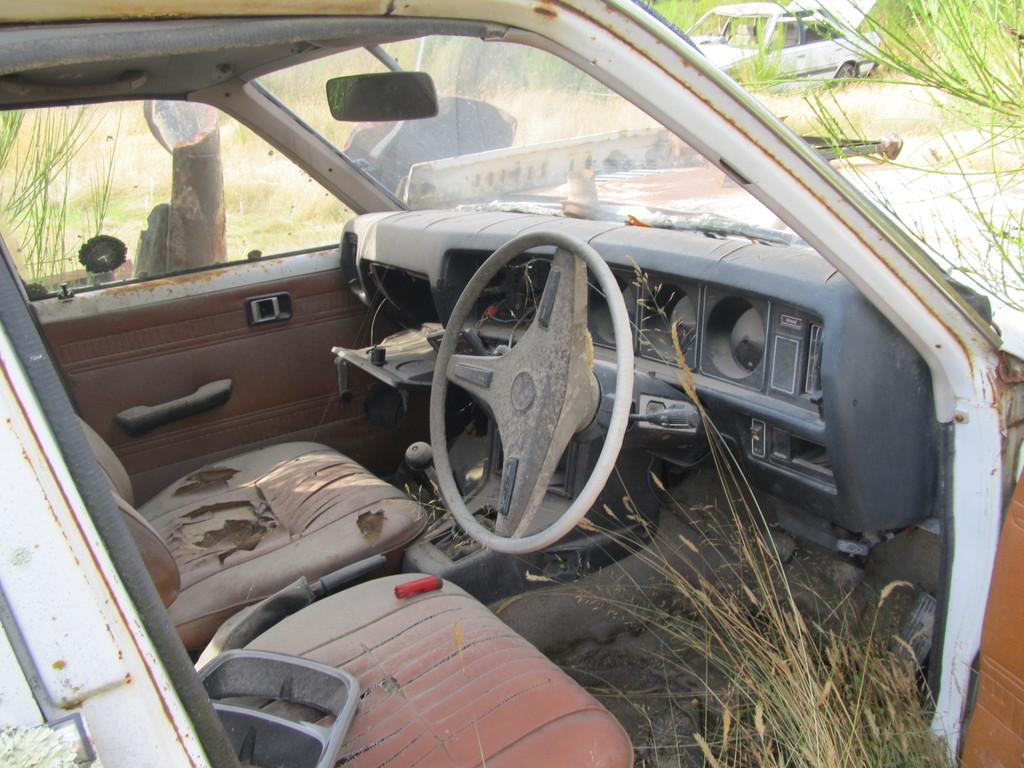In one or two sentences, can you explain what this image depicts? In this picture we can see a car and some grass on bottom right. There is a red object on the seat. We can see a vehicle in the background. 